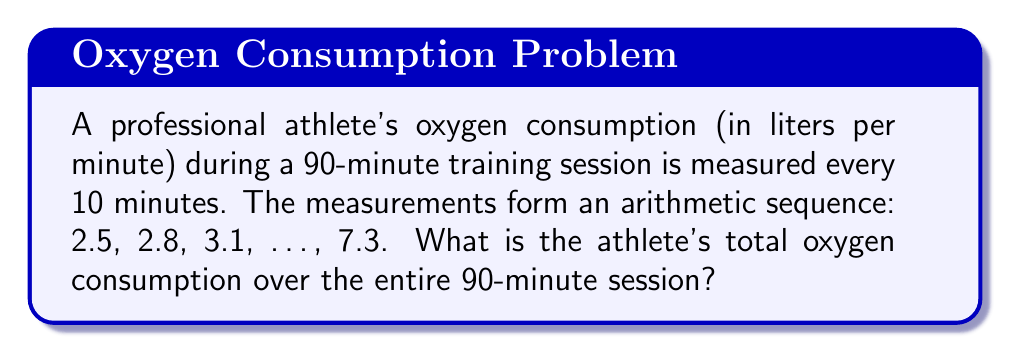Give your solution to this math problem. Let's approach this step-by-step:

1) First, we need to identify the arithmetic sequence:
   - First term $a_1 = 2.5$
   - Last term $a_{10} = 7.3$
   - Number of terms $n = 10$ (90 minutes ÷ 10 minutes = 9 intervals, so 10 measurements)

2) In an arithmetic sequence, the common difference $d$ is constant:
   $d = \frac{a_{10} - a_1}{n-1} = \frac{7.3 - 2.5}{9} = \frac{4.8}{9} = 0.533$

3) We can verify: $2.5 + 0.533 = 3.033 \approx 3.1$ (the second term)

4) To find the sum of an arithmetic sequence, we use the formula:
   $S_n = \frac{n}{2}(a_1 + a_n)$

5) Substituting our values:
   $S_{10} = \frac{10}{2}(2.5 + 7.3) = 5(9.8) = 49$

6) This gives us the sum of the measurements, but each measurement represents 10 minutes of oxygen consumption.

7) To get the total oxygen consumption, we multiply by 10:
   $49 \times 10 = 490$

Therefore, the total oxygen consumption over the 90-minute session is 490 liters.
Answer: 490 liters 